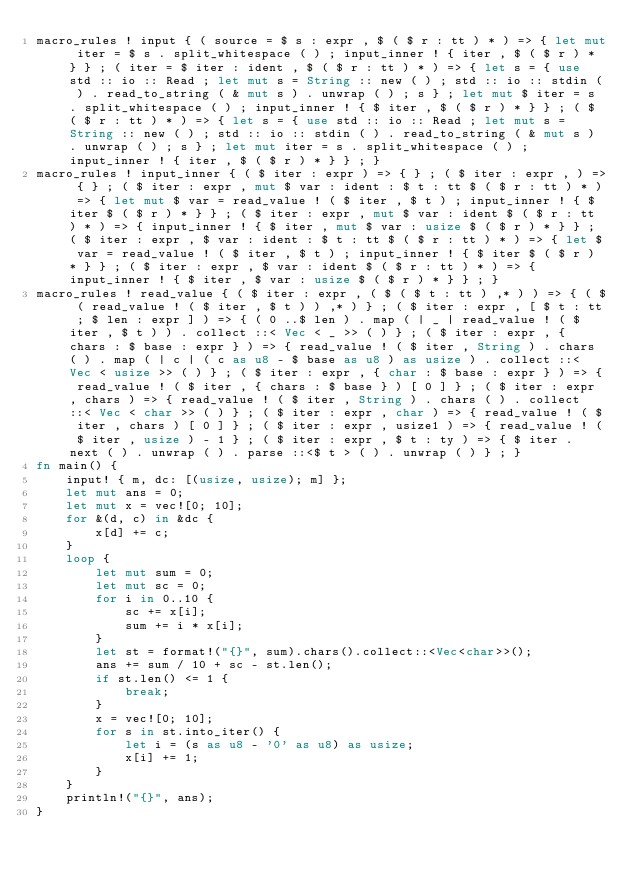<code> <loc_0><loc_0><loc_500><loc_500><_Rust_>macro_rules ! input { ( source = $ s : expr , $ ( $ r : tt ) * ) => { let mut iter = $ s . split_whitespace ( ) ; input_inner ! { iter , $ ( $ r ) * } } ; ( iter = $ iter : ident , $ ( $ r : tt ) * ) => { let s = { use std :: io :: Read ; let mut s = String :: new ( ) ; std :: io :: stdin ( ) . read_to_string ( & mut s ) . unwrap ( ) ; s } ; let mut $ iter = s . split_whitespace ( ) ; input_inner ! { $ iter , $ ( $ r ) * } } ; ( $ ( $ r : tt ) * ) => { let s = { use std :: io :: Read ; let mut s = String :: new ( ) ; std :: io :: stdin ( ) . read_to_string ( & mut s ) . unwrap ( ) ; s } ; let mut iter = s . split_whitespace ( ) ; input_inner ! { iter , $ ( $ r ) * } } ; }
macro_rules ! input_inner { ( $ iter : expr ) => { } ; ( $ iter : expr , ) => { } ; ( $ iter : expr , mut $ var : ident : $ t : tt $ ( $ r : tt ) * ) => { let mut $ var = read_value ! ( $ iter , $ t ) ; input_inner ! { $ iter $ ( $ r ) * } } ; ( $ iter : expr , mut $ var : ident $ ( $ r : tt ) * ) => { input_inner ! { $ iter , mut $ var : usize $ ( $ r ) * } } ; ( $ iter : expr , $ var : ident : $ t : tt $ ( $ r : tt ) * ) => { let $ var = read_value ! ( $ iter , $ t ) ; input_inner ! { $ iter $ ( $ r ) * } } ; ( $ iter : expr , $ var : ident $ ( $ r : tt ) * ) => { input_inner ! { $ iter , $ var : usize $ ( $ r ) * } } ; }
macro_rules ! read_value { ( $ iter : expr , ( $ ( $ t : tt ) ,* ) ) => { ( $ ( read_value ! ( $ iter , $ t ) ) ,* ) } ; ( $ iter : expr , [ $ t : tt ; $ len : expr ] ) => { ( 0 ..$ len ) . map ( | _ | read_value ! ( $ iter , $ t ) ) . collect ::< Vec < _ >> ( ) } ; ( $ iter : expr , { chars : $ base : expr } ) => { read_value ! ( $ iter , String ) . chars ( ) . map ( | c | ( c as u8 - $ base as u8 ) as usize ) . collect ::< Vec < usize >> ( ) } ; ( $ iter : expr , { char : $ base : expr } ) => { read_value ! ( $ iter , { chars : $ base } ) [ 0 ] } ; ( $ iter : expr , chars ) => { read_value ! ( $ iter , String ) . chars ( ) . collect ::< Vec < char >> ( ) } ; ( $ iter : expr , char ) => { read_value ! ( $ iter , chars ) [ 0 ] } ; ( $ iter : expr , usize1 ) => { read_value ! ( $ iter , usize ) - 1 } ; ( $ iter : expr , $ t : ty ) => { $ iter . next ( ) . unwrap ( ) . parse ::<$ t > ( ) . unwrap ( ) } ; }
fn main() {
    input! { m, dc: [(usize, usize); m] };
    let mut ans = 0;
    let mut x = vec![0; 10];
    for &(d, c) in &dc {
        x[d] += c;
    }
    loop {
        let mut sum = 0;
        let mut sc = 0;
        for i in 0..10 {
            sc += x[i];
            sum += i * x[i];
        }
        let st = format!("{}", sum).chars().collect::<Vec<char>>();
        ans += sum / 10 + sc - st.len();
        if st.len() <= 1 {
            break;
        }
        x = vec![0; 10];
        for s in st.into_iter() {
            let i = (s as u8 - '0' as u8) as usize;
            x[i] += 1;
        }
    }
    println!("{}", ans);
}
</code> 